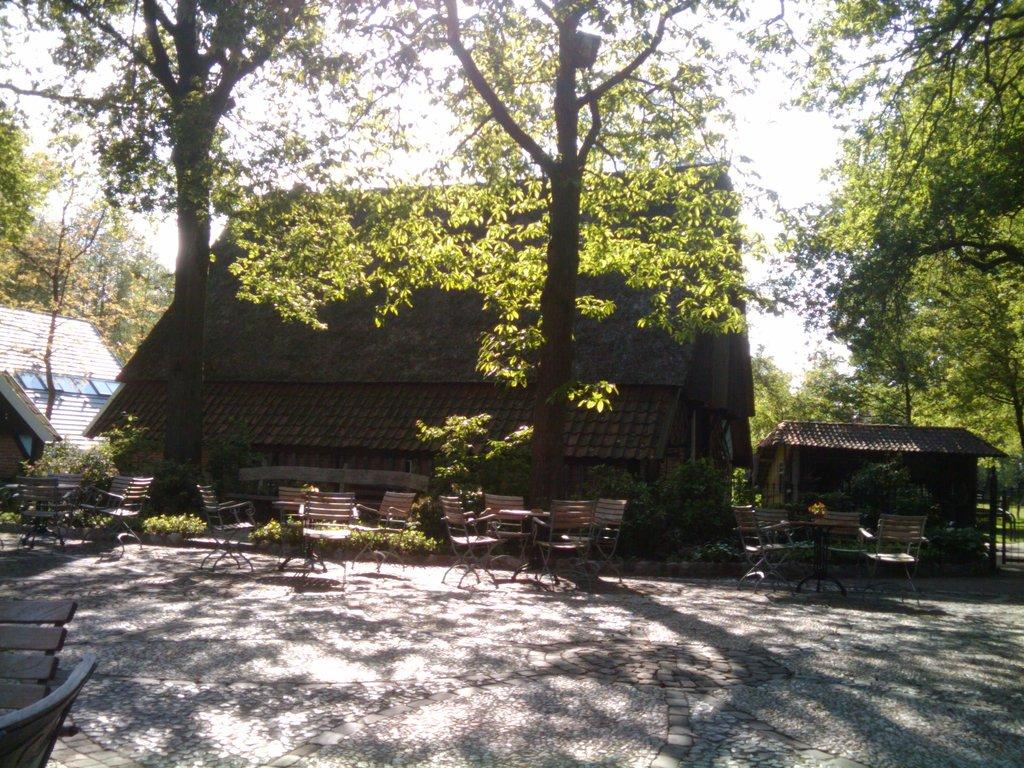What type of furniture is present in the image? There are chairs in the image. What can be seen in the background of the image? There is a building and trees in the background of the image. What is the color of the building in the image? The building is maroon in color. What is the color of the trees in the image? The trees are green in color. What is visible in the sky in the image? The sky is visible in the background of the image. What is the color of the sky in the image? The sky is white in color. What type of police cannon is present in the image? There is no police cannon present in the image. What is the color of the thing in the image? The question is too vague to answer definitively, as there are multiple objects in the image with different colors. Please specify which object you are referring to. 